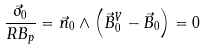<formula> <loc_0><loc_0><loc_500><loc_500>\frac { \vec { \sigma } _ { 0 } } { R B _ { p } } = \vec { n } _ { 0 } \wedge \left ( \vec { B } _ { 0 } ^ { V } - \vec { B } _ { 0 } \right ) = 0</formula> 